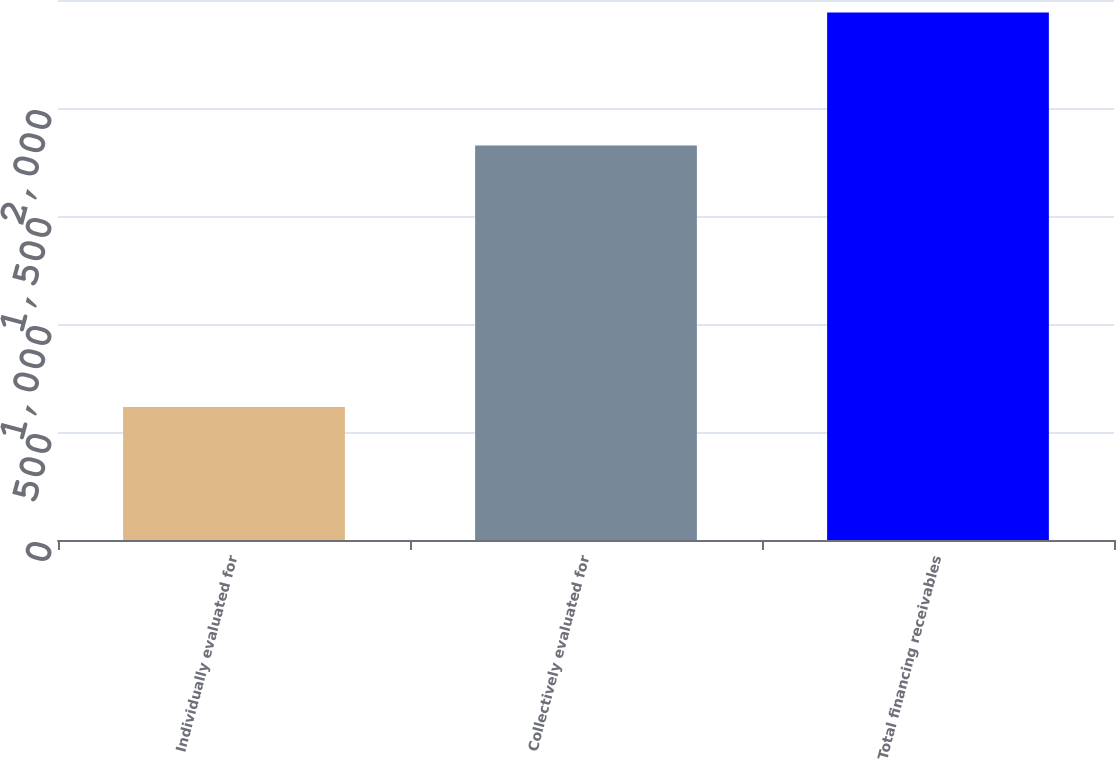Convert chart to OTSL. <chart><loc_0><loc_0><loc_500><loc_500><bar_chart><fcel>Individually evaluated for<fcel>Collectively evaluated for<fcel>Total financing receivables<nl><fcel>616<fcel>1826<fcel>2442<nl></chart> 